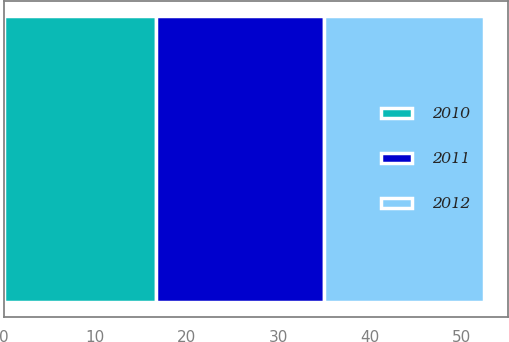<chart> <loc_0><loc_0><loc_500><loc_500><stacked_bar_chart><ecel><fcel>Unnamed: 1<nl><fcel>2012<fcel>17.47<nl><fcel>2011<fcel>18.29<nl><fcel>2010<fcel>16.68<nl></chart> 